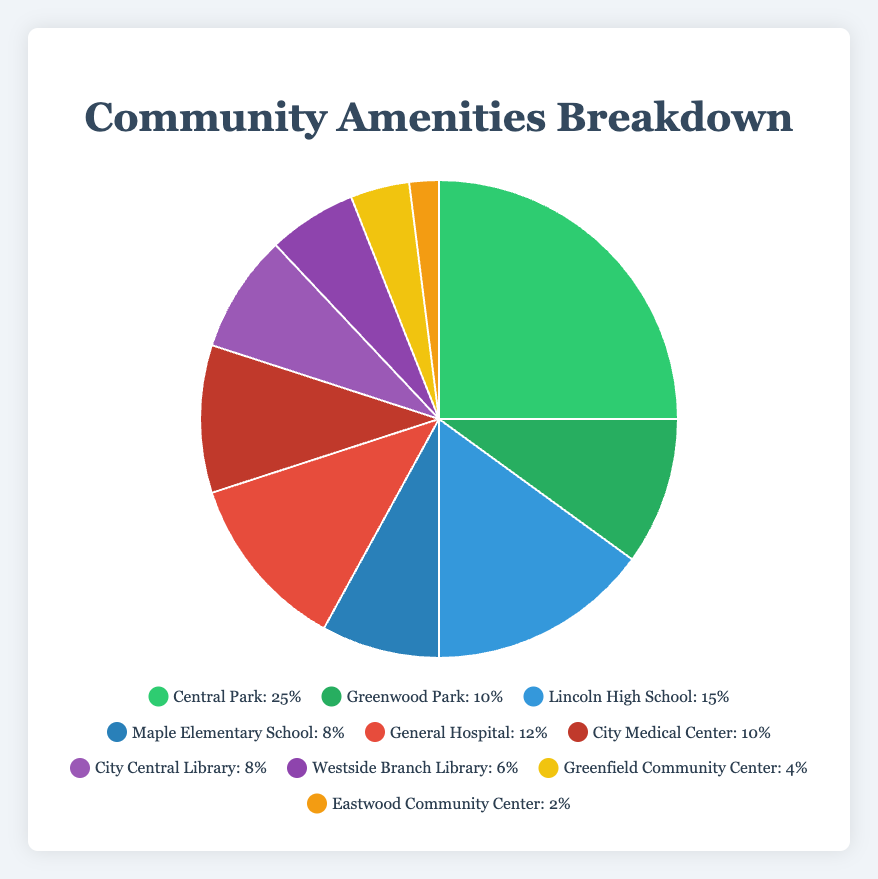Which amenity has the largest percentage in the pie chart? The largest percentage is represented by the biggest segment of the pie chart. Central Park has a 25% share, which is the largest.
Answer: Central Park What is the total percentage of parks combined? Add the percentages of all areas categorized as parks: Central Park (25%) + Greenwood Park (10%) = 35%.
Answer: 35% What is the difference in percentage between Lincoln High School and General Hospital? Subtract the percentage of General Hospital (12%) from Lincoln High School (15%): 15% - 12% = 3%.
Answer: 3% Which amenity is represented by the red segment in the chart? The red segment corresponds to General Hospital, which has a 12% share.
Answer: General Hospital What is the average percentage of schools within the community? Add the percentages for Lincoln High School (15%) and Maple Elementary School (8%), then divide by the number of school amenities (2): (15% + 8%) / 2 = 11.5%.
Answer: 11.5% Compare the percentage share of libraries and community centers. Which has a higher percentage? Libraries have a combined percentage of City Central Library (8%) + Westside Branch Library (6%) = 14%. Community Centers have a total of Greenfield Community Center (4%) + Eastwood Community Center (2%) = 6%. Libraries have a higher percentage.
Answer: Libraries What is the combined percentage of all types of schools, hospitals, and community centers? Sum the percentages of all schools (15% + 8%), hospitals (12% + 10%), and community centers (4% + 2%): 15% + 8% + 12% + 10% + 4% + 2% = 51%.
Answer: 51% Which amenity has the smallest representation in the pie chart? The smallest percentage is represented by the smallest segment of the pie chart, which is Eastwood Community Center at 2%.
Answer: Eastwood Community Center If we were to group the amenities into broader categories, such as outdoor (parks) and indoor (schools, hospitals, libraries, community centers), which category has a higher percentage? The total percentage for parks (outdoor) is 25% + 10% = 35%. Summing the indoor amenities: schools (15% + 8%) + hospitals (12% + 10%) + libraries (8% + 6%) + community centers (4% + 2%): 23% + 22% + 14% + 6% = 65%. Indoor amenities have a higher percentage.
Answer: Indoor amenities 